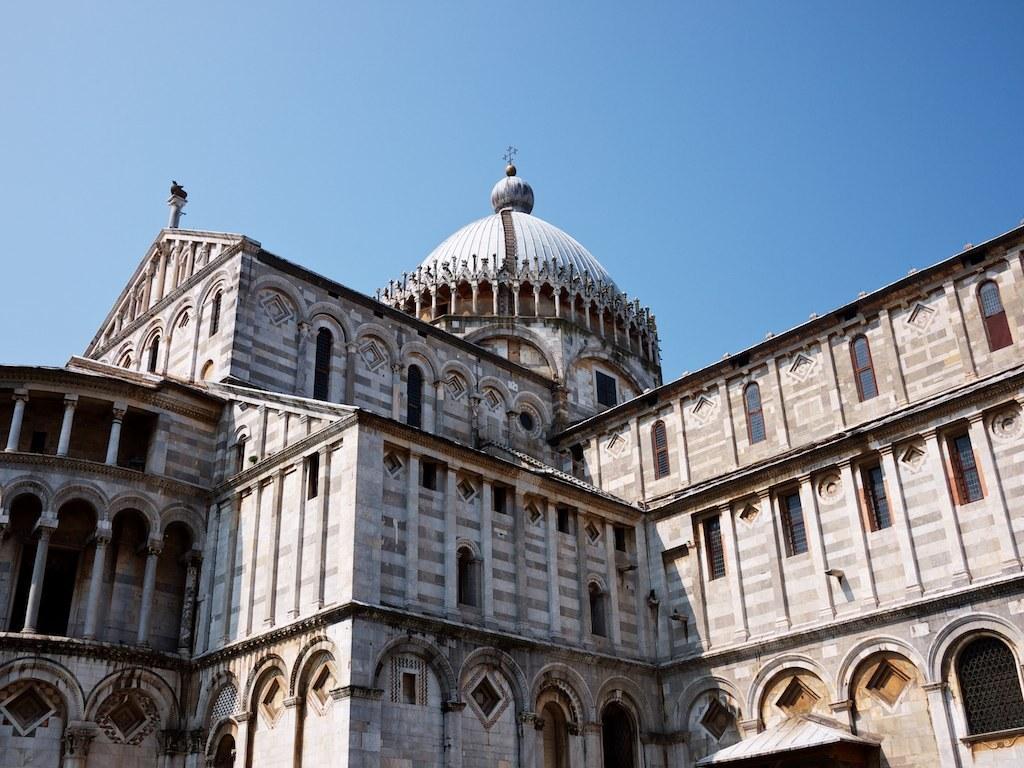Could you give a brief overview of what you see in this image? In this image we can see building with pillars, windows. At the top of the image there is sky. 